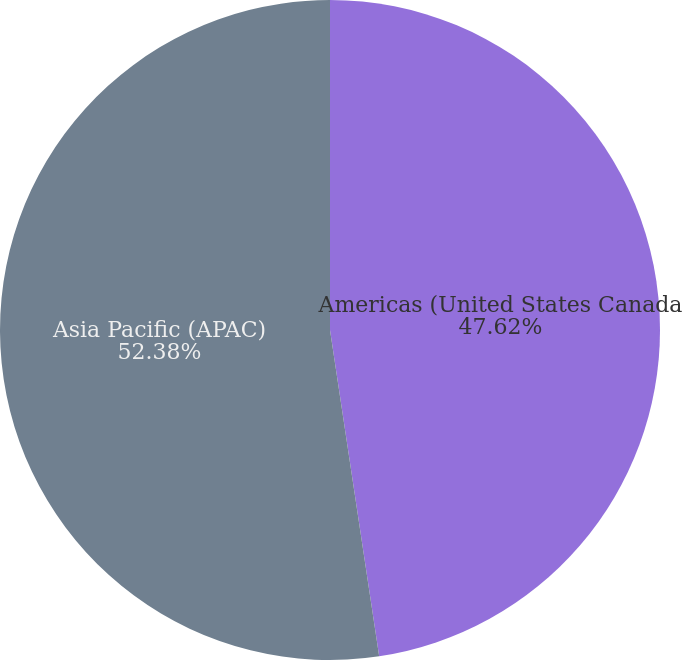<chart> <loc_0><loc_0><loc_500><loc_500><pie_chart><fcel>Americas (United States Canada<fcel>Asia Pacific (APAC)<nl><fcel>47.62%<fcel>52.38%<nl></chart> 